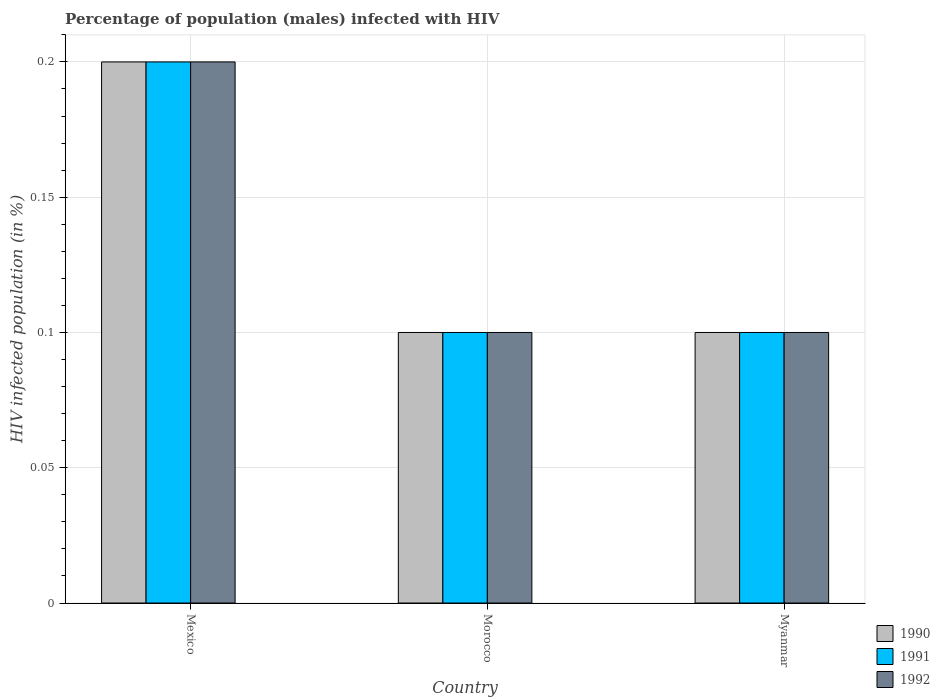Are the number of bars per tick equal to the number of legend labels?
Your response must be concise. Yes. How many bars are there on the 1st tick from the left?
Offer a terse response. 3. How many bars are there on the 3rd tick from the right?
Your answer should be compact. 3. In how many cases, is the number of bars for a given country not equal to the number of legend labels?
Your answer should be compact. 0. Across all countries, what is the maximum percentage of HIV infected male population in 1992?
Make the answer very short. 0.2. In which country was the percentage of HIV infected male population in 1990 minimum?
Your answer should be very brief. Morocco. What is the total percentage of HIV infected male population in 1990 in the graph?
Your answer should be compact. 0.4. What is the difference between the percentage of HIV infected male population in 1990 in Mexico and that in Myanmar?
Provide a short and direct response. 0.1. What is the average percentage of HIV infected male population in 1991 per country?
Ensure brevity in your answer.  0.13. In how many countries, is the percentage of HIV infected male population in 1992 greater than 0.04 %?
Provide a short and direct response. 3. What is the difference between the highest and the second highest percentage of HIV infected male population in 1992?
Give a very brief answer. 0.1. In how many countries, is the percentage of HIV infected male population in 1991 greater than the average percentage of HIV infected male population in 1991 taken over all countries?
Your answer should be compact. 1. Is the sum of the percentage of HIV infected male population in 1991 in Mexico and Myanmar greater than the maximum percentage of HIV infected male population in 1992 across all countries?
Keep it short and to the point. Yes. What does the 3rd bar from the left in Mexico represents?
Offer a very short reply. 1992. What does the 1st bar from the right in Mexico represents?
Keep it short and to the point. 1992. How many bars are there?
Ensure brevity in your answer.  9. Are all the bars in the graph horizontal?
Keep it short and to the point. No. How many countries are there in the graph?
Give a very brief answer. 3. Are the values on the major ticks of Y-axis written in scientific E-notation?
Offer a terse response. No. Does the graph contain grids?
Offer a terse response. Yes. Where does the legend appear in the graph?
Your response must be concise. Bottom right. What is the title of the graph?
Ensure brevity in your answer.  Percentage of population (males) infected with HIV. What is the label or title of the X-axis?
Your response must be concise. Country. What is the label or title of the Y-axis?
Provide a short and direct response. HIV infected population (in %). What is the HIV infected population (in %) of 1990 in Mexico?
Offer a terse response. 0.2. What is the HIV infected population (in %) of 1991 in Mexico?
Provide a short and direct response. 0.2. What is the HIV infected population (in %) in 1992 in Mexico?
Offer a very short reply. 0.2. What is the HIV infected population (in %) in 1991 in Myanmar?
Keep it short and to the point. 0.1. What is the HIV infected population (in %) in 1992 in Myanmar?
Offer a very short reply. 0.1. Across all countries, what is the maximum HIV infected population (in %) of 1991?
Offer a very short reply. 0.2. Across all countries, what is the minimum HIV infected population (in %) in 1990?
Offer a terse response. 0.1. What is the total HIV infected population (in %) in 1990 in the graph?
Your answer should be very brief. 0.4. What is the total HIV infected population (in %) of 1991 in the graph?
Ensure brevity in your answer.  0.4. What is the difference between the HIV infected population (in %) of 1990 in Mexico and that in Morocco?
Offer a very short reply. 0.1. What is the difference between the HIV infected population (in %) in 1992 in Mexico and that in Morocco?
Provide a succinct answer. 0.1. What is the difference between the HIV infected population (in %) of 1992 in Mexico and that in Myanmar?
Provide a short and direct response. 0.1. What is the difference between the HIV infected population (in %) in 1990 in Morocco and that in Myanmar?
Ensure brevity in your answer.  0. What is the difference between the HIV infected population (in %) of 1991 in Morocco and that in Myanmar?
Offer a very short reply. 0. What is the difference between the HIV infected population (in %) in 1992 in Morocco and that in Myanmar?
Offer a terse response. 0. What is the difference between the HIV infected population (in %) of 1991 in Mexico and the HIV infected population (in %) of 1992 in Morocco?
Make the answer very short. 0.1. What is the difference between the HIV infected population (in %) of 1991 in Mexico and the HIV infected population (in %) of 1992 in Myanmar?
Ensure brevity in your answer.  0.1. What is the difference between the HIV infected population (in %) in 1990 in Morocco and the HIV infected population (in %) in 1991 in Myanmar?
Your answer should be compact. 0. What is the difference between the HIV infected population (in %) in 1990 in Morocco and the HIV infected population (in %) in 1992 in Myanmar?
Give a very brief answer. 0. What is the difference between the HIV infected population (in %) in 1991 in Morocco and the HIV infected population (in %) in 1992 in Myanmar?
Keep it short and to the point. 0. What is the average HIV infected population (in %) in 1990 per country?
Your answer should be compact. 0.13. What is the average HIV infected population (in %) in 1991 per country?
Provide a short and direct response. 0.13. What is the average HIV infected population (in %) in 1992 per country?
Your answer should be very brief. 0.13. What is the difference between the HIV infected population (in %) in 1990 and HIV infected population (in %) in 1991 in Mexico?
Offer a very short reply. 0. What is the difference between the HIV infected population (in %) in 1990 and HIV infected population (in %) in 1992 in Mexico?
Ensure brevity in your answer.  0. What is the difference between the HIV infected population (in %) of 1990 and HIV infected population (in %) of 1991 in Morocco?
Give a very brief answer. 0. What is the difference between the HIV infected population (in %) in 1991 and HIV infected population (in %) in 1992 in Morocco?
Ensure brevity in your answer.  0. What is the difference between the HIV infected population (in %) in 1990 and HIV infected population (in %) in 1992 in Myanmar?
Your answer should be compact. 0. What is the difference between the HIV infected population (in %) of 1991 and HIV infected population (in %) of 1992 in Myanmar?
Offer a very short reply. 0. What is the ratio of the HIV infected population (in %) of 1990 in Mexico to that in Morocco?
Keep it short and to the point. 2. What is the ratio of the HIV infected population (in %) of 1991 in Mexico to that in Morocco?
Ensure brevity in your answer.  2. What is the ratio of the HIV infected population (in %) in 1991 in Mexico to that in Myanmar?
Keep it short and to the point. 2. What is the ratio of the HIV infected population (in %) of 1992 in Mexico to that in Myanmar?
Your answer should be compact. 2. What is the ratio of the HIV infected population (in %) of 1991 in Morocco to that in Myanmar?
Offer a very short reply. 1. What is the difference between the highest and the second highest HIV infected population (in %) in 1992?
Keep it short and to the point. 0.1. What is the difference between the highest and the lowest HIV infected population (in %) in 1991?
Your answer should be very brief. 0.1. 